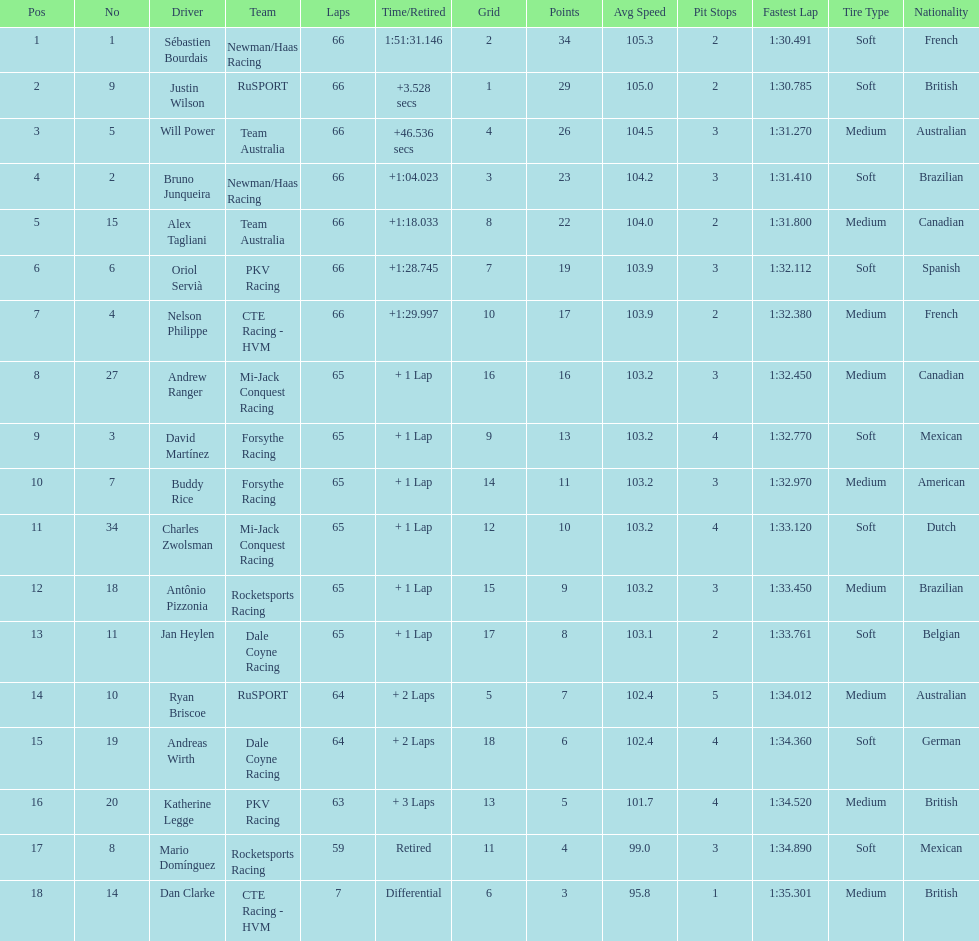At the 2006 gran premio telmex, who scored the highest number of points? Sébastien Bourdais. 